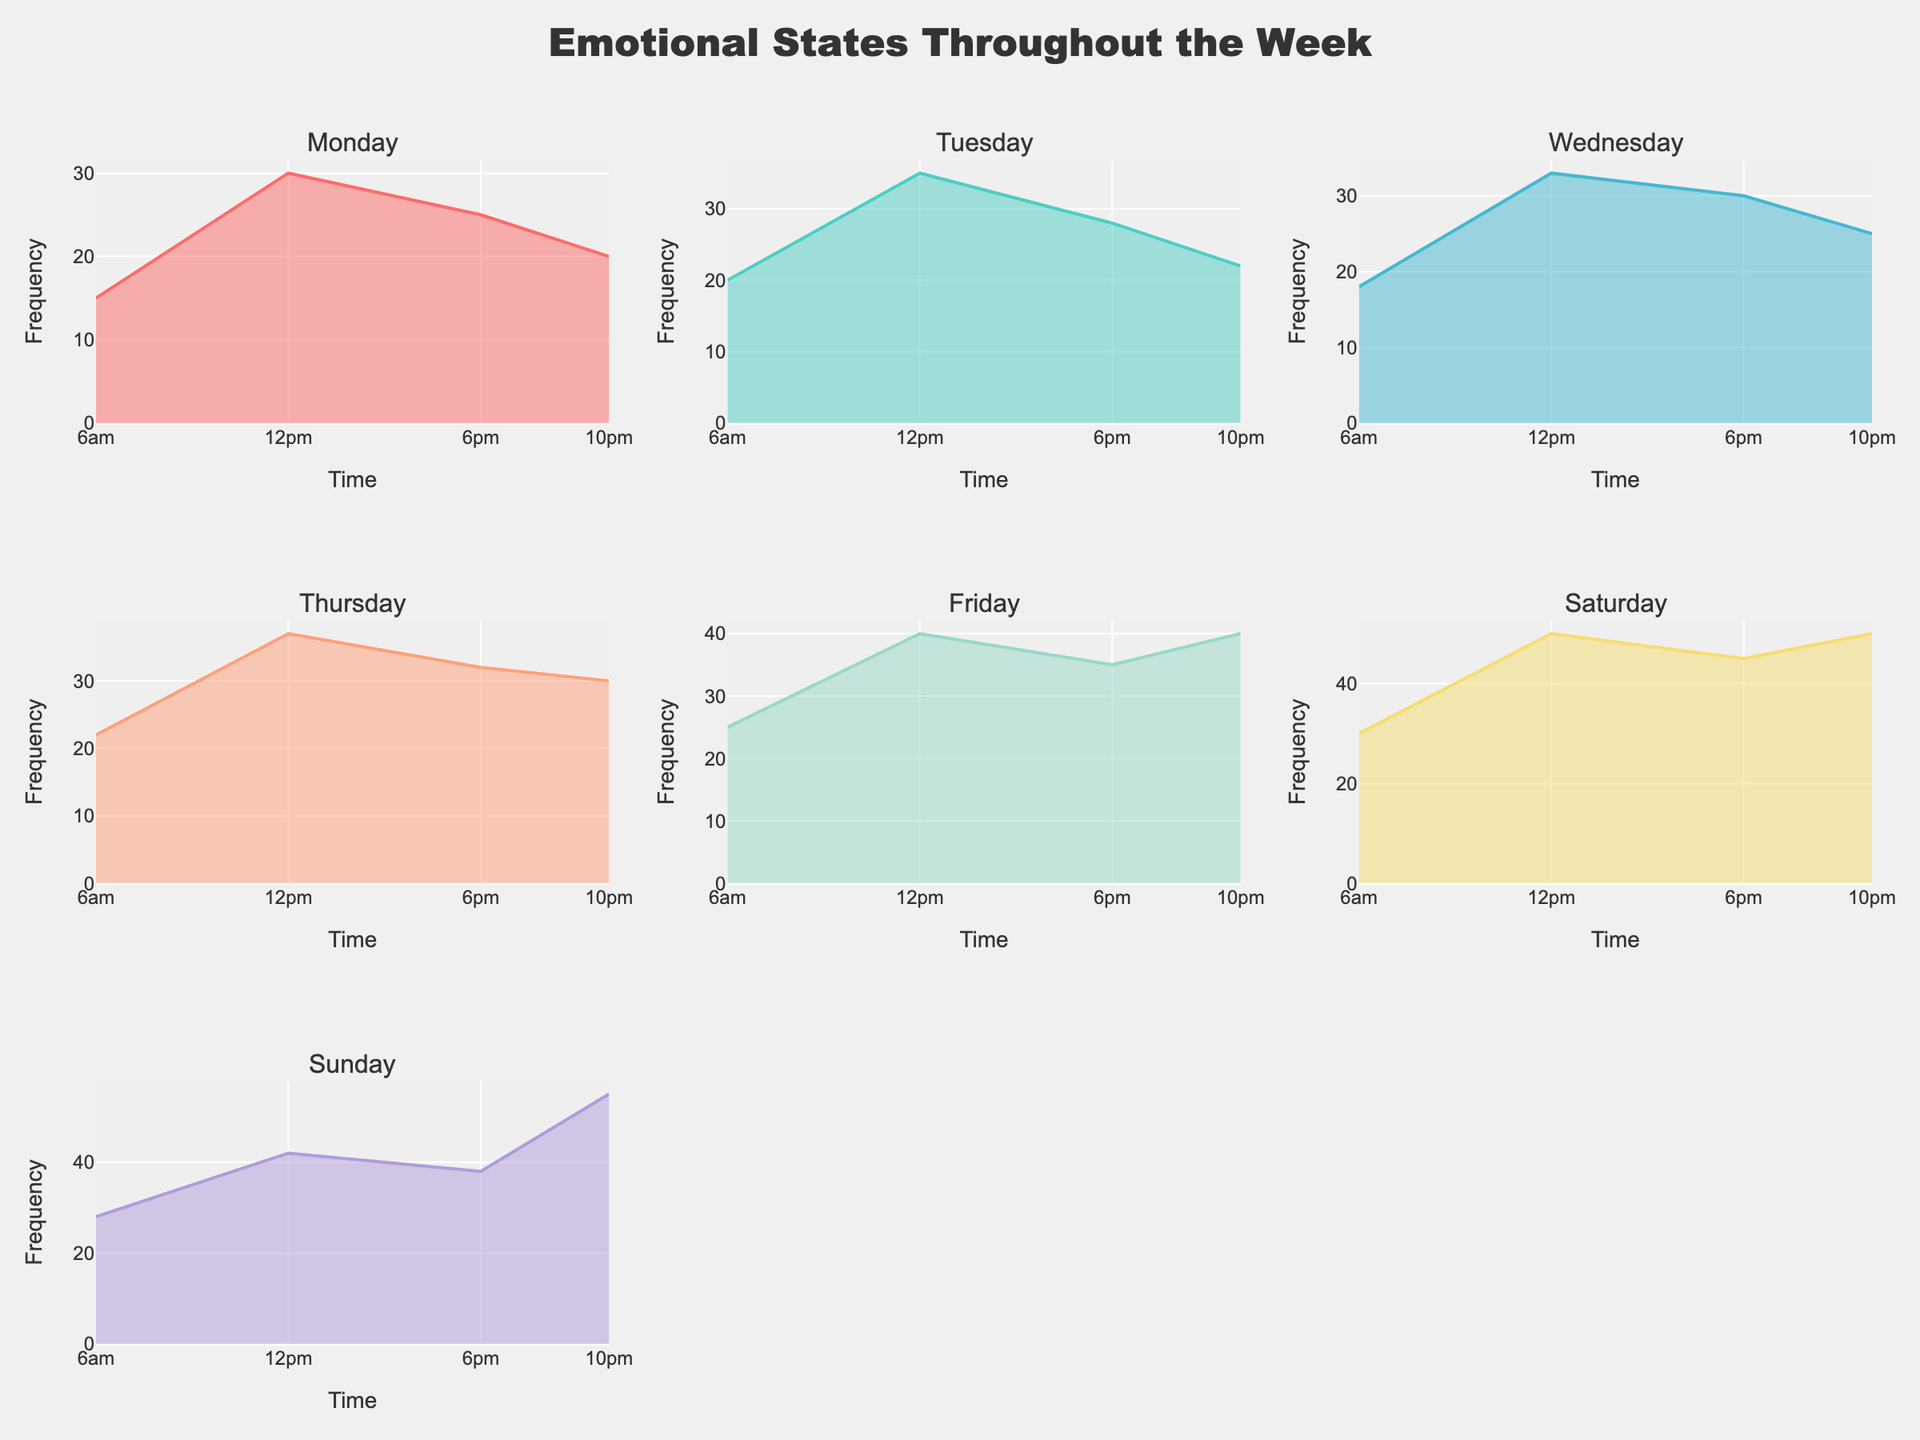How many different emotional states are there for Saturday? Look at the subplot titled "Saturday" and count the distinct peaks representing different emotional states.
Answer: 4 What time of day is associated with the highest frequency on Sunday? Find the peak of the curve in the Sunday subplot and check the corresponding time on the x-axis.
Answer: 10pm Which day of the week has the highest frequency overall? Identify which subplot has the highest single peak by comparing the maximum points across all subplots.
Answer: Sunday How does the emotional state frequency at 6pm compare between Tuesday and Friday? Compare the y-values at 6pm in the Tuesday and Friday subplots.
Answer: Tuesday is lower than Friday What is the trend of the emotional state frequency throughout the day on Monday? Observe the shape of the curve in Monday's subplot to identify whether it increases, decreases, or has peaks at specific times.
Answer: Increases at noon, declines in the evening, then peaks again at night Which day shows the trend of growing emotional intensity from morning to night? Identify the subplot where the curve rises from morning to night without any significant dips.
Answer: Saturday Is there any day where the emotional state frequency is relatively stable throughout the day? Look at each subplot to find a day whose curve has minimal fluctuation.
Answer: None What are the emotional states at 6am across the week? Identify the peaks at 6am in all subplots and note the corresponding emotional states.
Answer: Tranquil, Optimistic, Calm, Hopeful, Cheerful, Relaxed, Mellow How does the frequency of nighttime emotional states compare between Thursday and Saturday? Observe the y-values at 10pm for both Thursday and Saturday subplots and compare them.
Answer: Saturday is higher than Thursday 